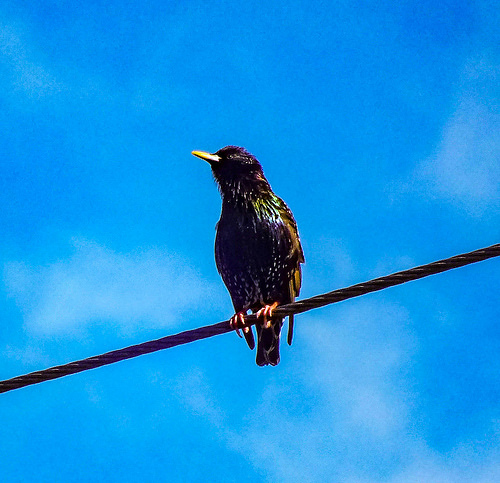<image>
Is there a wire under the bird? Yes. The wire is positioned underneath the bird, with the bird above it in the vertical space. 